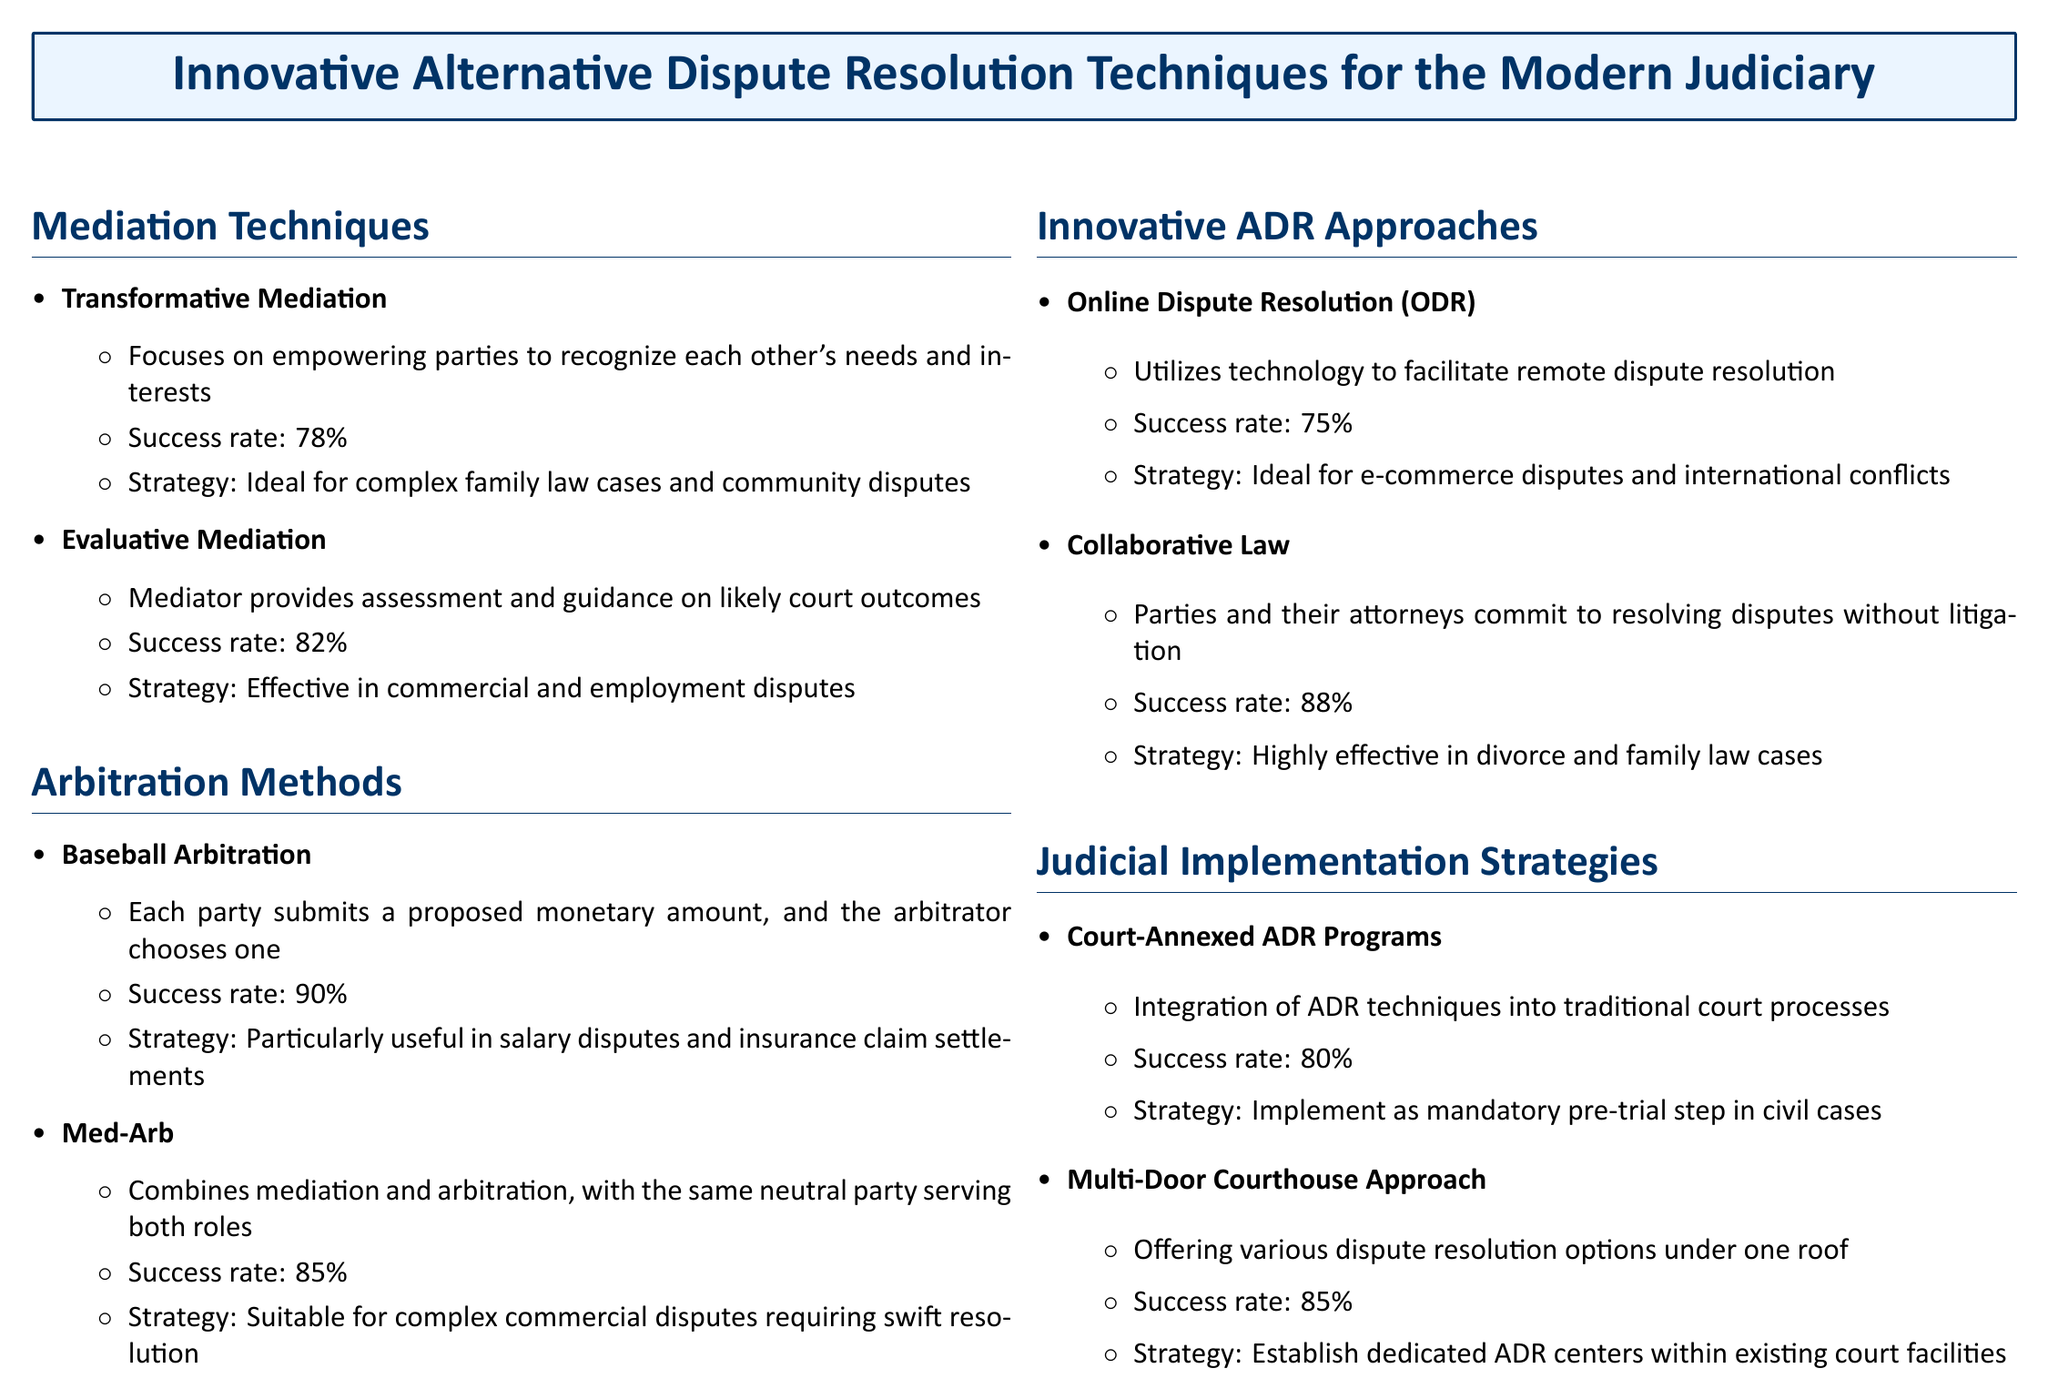What is the success rate of Transformative Mediation? The success rate is stated in the document as 78%.
Answer: 78% What type of disputes is Baseball Arbitration particularly useful for? The document specifies that Baseball Arbitration is particularly useful in salary disputes and insurance claim settlements.
Answer: Salary disputes and insurance claim settlements What does Med-Arb combine? The document explains that Med-Arb combines mediation and arbitration.
Answer: Mediation and arbitration What is the success rate of Collaborative Law? The success rate is indicated as 88% in the document.
Answer: 88% What is the implementation strategy for Court-Annexed ADR Programs? The document states that the strategy is to implement as a mandatory pre-trial step in civil cases.
Answer: Mandatory pre-trial step in civil cases What type of ADR method utilizes technology? The document mentions Online Dispute Resolution (ODR) as the method that utilizes technology.
Answer: Online Dispute Resolution (ODR) What is the success rate of Evaluative Mediation? The document lists the success rate as 82%.
Answer: 82% What innovative approach offers various dispute resolution options under one roof? The document describes the Multi-Door Courthouse Approach as offering various dispute resolution options under one roof.
Answer: Multi-Door Courthouse Approach 